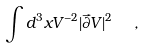<formula> <loc_0><loc_0><loc_500><loc_500>\int d ^ { 3 } x V ^ { - 2 } | \vec { \partial } V | ^ { 2 } \ \ ,</formula> 